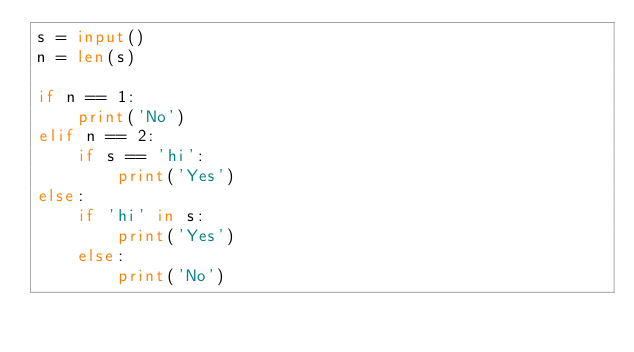<code> <loc_0><loc_0><loc_500><loc_500><_Python_>s = input()
n = len(s)

if n == 1:
    print('No')
elif n == 2:
    if s == 'hi':
        print('Yes')
else:
    if 'hi' in s:
        print('Yes')
    else:
        print('No') </code> 